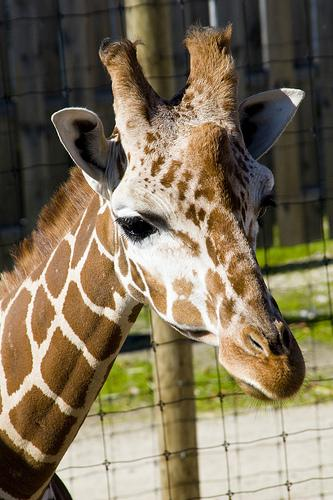Question: what animal is this?
Choices:
A. A zebra.
B. A giraffe.
C. An elephant.
D. A horse.
Answer with the letter. Answer: B Question: what color is the giraffe?
Choices:
A. Black and yellow.
B. Beige and white.
C. Brown and beige.
D. Brown and white.
Answer with the letter. Answer: D Question: how many giraffes are there?
Choices:
A. Two.
B. One.
C. Three.
D. Five.
Answer with the letter. Answer: B Question: how much of the giraffe can be seen?
Choices:
A. Legs.
B. Head and neck.
C. Tail.
D. Foot.
Answer with the letter. Answer: B 